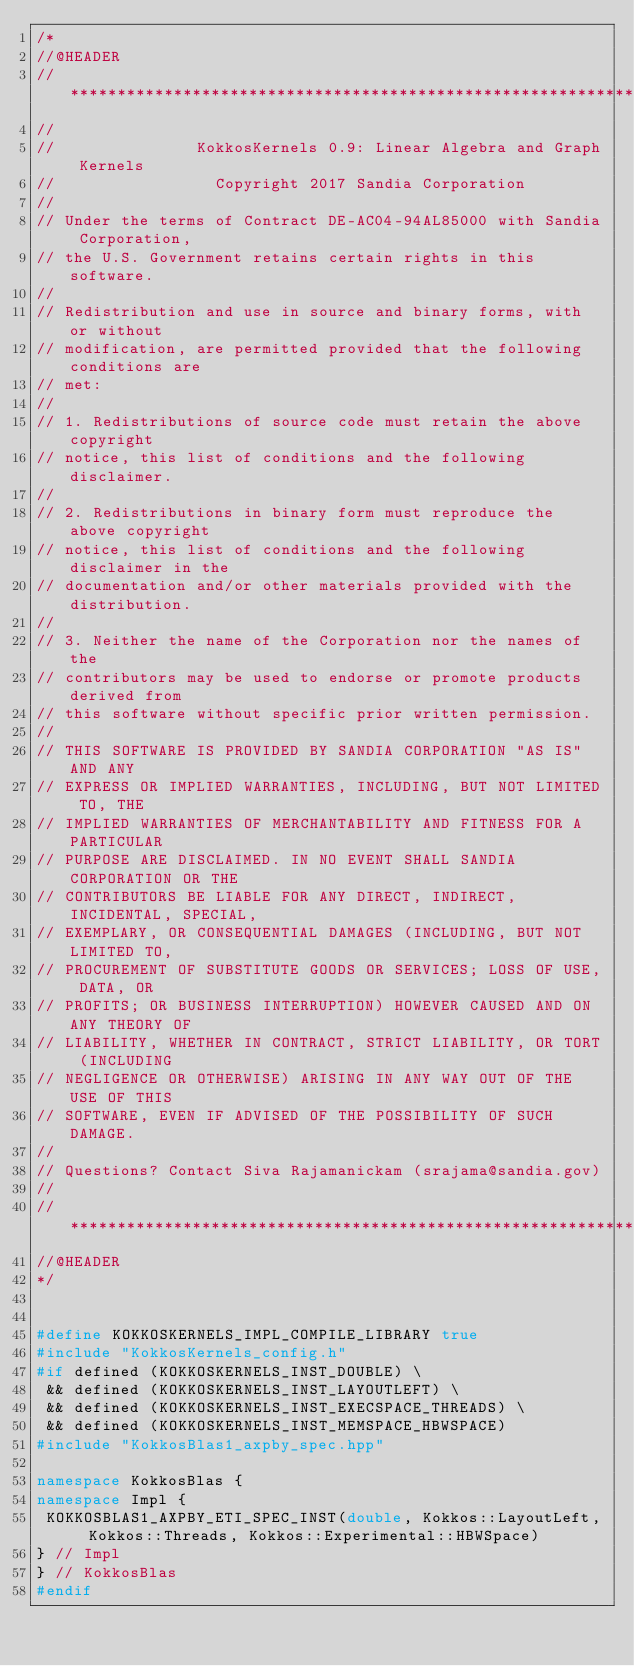Convert code to text. <code><loc_0><loc_0><loc_500><loc_500><_C++_>/*
//@HEADER
// ************************************************************************
//
//               KokkosKernels 0.9: Linear Algebra and Graph Kernels
//                 Copyright 2017 Sandia Corporation
//
// Under the terms of Contract DE-AC04-94AL85000 with Sandia Corporation,
// the U.S. Government retains certain rights in this software.
//
// Redistribution and use in source and binary forms, with or without
// modification, are permitted provided that the following conditions are
// met:
//
// 1. Redistributions of source code must retain the above copyright
// notice, this list of conditions and the following disclaimer.
//
// 2. Redistributions in binary form must reproduce the above copyright
// notice, this list of conditions and the following disclaimer in the
// documentation and/or other materials provided with the distribution.
//
// 3. Neither the name of the Corporation nor the names of the
// contributors may be used to endorse or promote products derived from
// this software without specific prior written permission.
//
// THIS SOFTWARE IS PROVIDED BY SANDIA CORPORATION "AS IS" AND ANY
// EXPRESS OR IMPLIED WARRANTIES, INCLUDING, BUT NOT LIMITED TO, THE
// IMPLIED WARRANTIES OF MERCHANTABILITY AND FITNESS FOR A PARTICULAR
// PURPOSE ARE DISCLAIMED. IN NO EVENT SHALL SANDIA CORPORATION OR THE
// CONTRIBUTORS BE LIABLE FOR ANY DIRECT, INDIRECT, INCIDENTAL, SPECIAL,
// EXEMPLARY, OR CONSEQUENTIAL DAMAGES (INCLUDING, BUT NOT LIMITED TO,
// PROCUREMENT OF SUBSTITUTE GOODS OR SERVICES; LOSS OF USE, DATA, OR
// PROFITS; OR BUSINESS INTERRUPTION) HOWEVER CAUSED AND ON ANY THEORY OF
// LIABILITY, WHETHER IN CONTRACT, STRICT LIABILITY, OR TORT (INCLUDING
// NEGLIGENCE OR OTHERWISE) ARISING IN ANY WAY OUT OF THE USE OF THIS
// SOFTWARE, EVEN IF ADVISED OF THE POSSIBILITY OF SUCH DAMAGE.
//
// Questions? Contact Siva Rajamanickam (srajama@sandia.gov)
//
// ************************************************************************
//@HEADER
*/


#define KOKKOSKERNELS_IMPL_COMPILE_LIBRARY true
#include "KokkosKernels_config.h"
#if defined (KOKKOSKERNELS_INST_DOUBLE) \
 && defined (KOKKOSKERNELS_INST_LAYOUTLEFT) \
 && defined (KOKKOSKERNELS_INST_EXECSPACE_THREADS) \
 && defined (KOKKOSKERNELS_INST_MEMSPACE_HBWSPACE)
#include "KokkosBlas1_axpby_spec.hpp"

namespace KokkosBlas {
namespace Impl {
 KOKKOSBLAS1_AXPBY_ETI_SPEC_INST(double, Kokkos::LayoutLeft, Kokkos::Threads, Kokkos::Experimental::HBWSpace)
} // Impl
} // KokkosBlas
#endif
</code> 